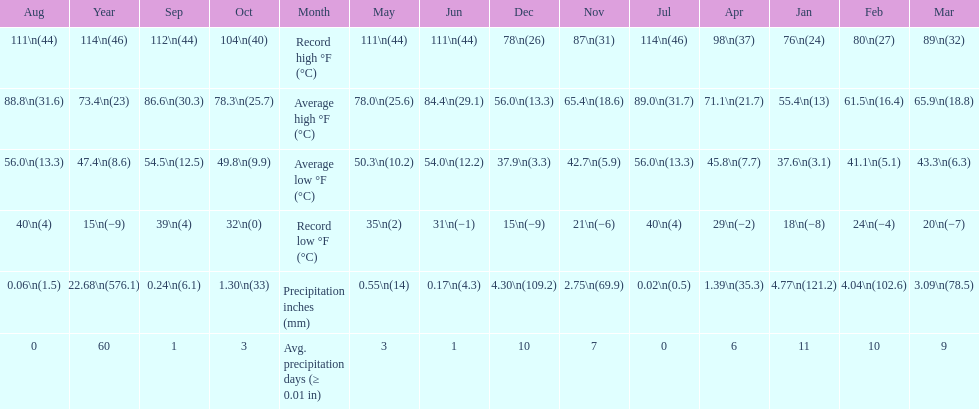How many months had a record high of 111 degrees? 3. 